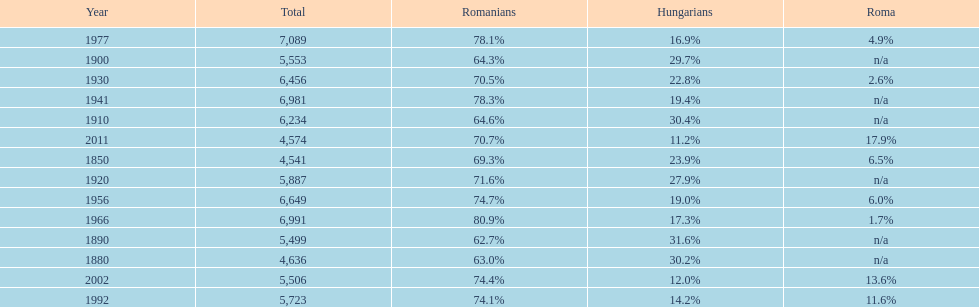What percent of the population were romanians according to the last year on this chart? 70.7%. 